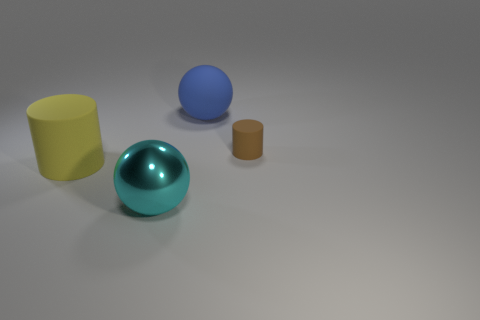Add 2 large matte spheres. How many objects exist? 6 Add 1 spheres. How many spheres are left? 3 Add 4 blue spheres. How many blue spheres exist? 5 Subtract 0 green spheres. How many objects are left? 4 Subtract all large matte spheres. Subtract all blue matte objects. How many objects are left? 2 